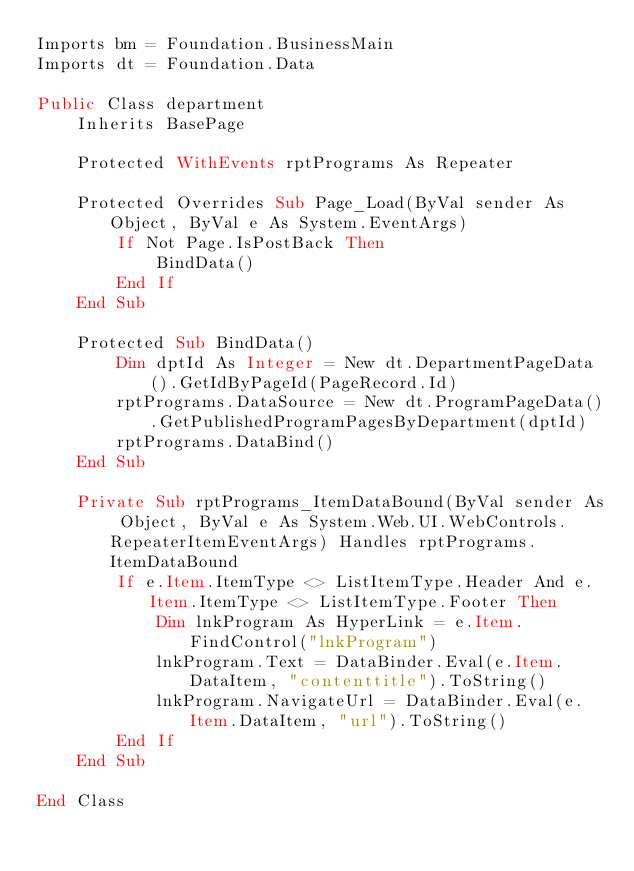Convert code to text. <code><loc_0><loc_0><loc_500><loc_500><_VisualBasic_>Imports bm = Foundation.BusinessMain
Imports dt = Foundation.Data

Public Class department
    Inherits BasePage

    Protected WithEvents rptPrograms As Repeater

    Protected Overrides Sub Page_Load(ByVal sender As Object, ByVal e As System.EventArgs)
        If Not Page.IsPostBack Then
            BindData()
        End If
    End Sub

    Protected Sub BindData()
        Dim dptId As Integer = New dt.DepartmentPageData().GetIdByPageId(PageRecord.Id)
        rptPrograms.DataSource = New dt.ProgramPageData().GetPublishedProgramPagesByDepartment(dptId)
        rptPrograms.DataBind()
    End Sub

    Private Sub rptPrograms_ItemDataBound(ByVal sender As Object, ByVal e As System.Web.UI.WebControls.RepeaterItemEventArgs) Handles rptPrograms.ItemDataBound
        If e.Item.ItemType <> ListItemType.Header And e.Item.ItemType <> ListItemType.Footer Then
            Dim lnkProgram As HyperLink = e.Item.FindControl("lnkProgram")
            lnkProgram.Text = DataBinder.Eval(e.Item.DataItem, "contenttitle").ToString()
            lnkProgram.NavigateUrl = DataBinder.Eval(e.Item.DataItem, "url").ToString()
        End If
    End Sub

End Class
</code> 